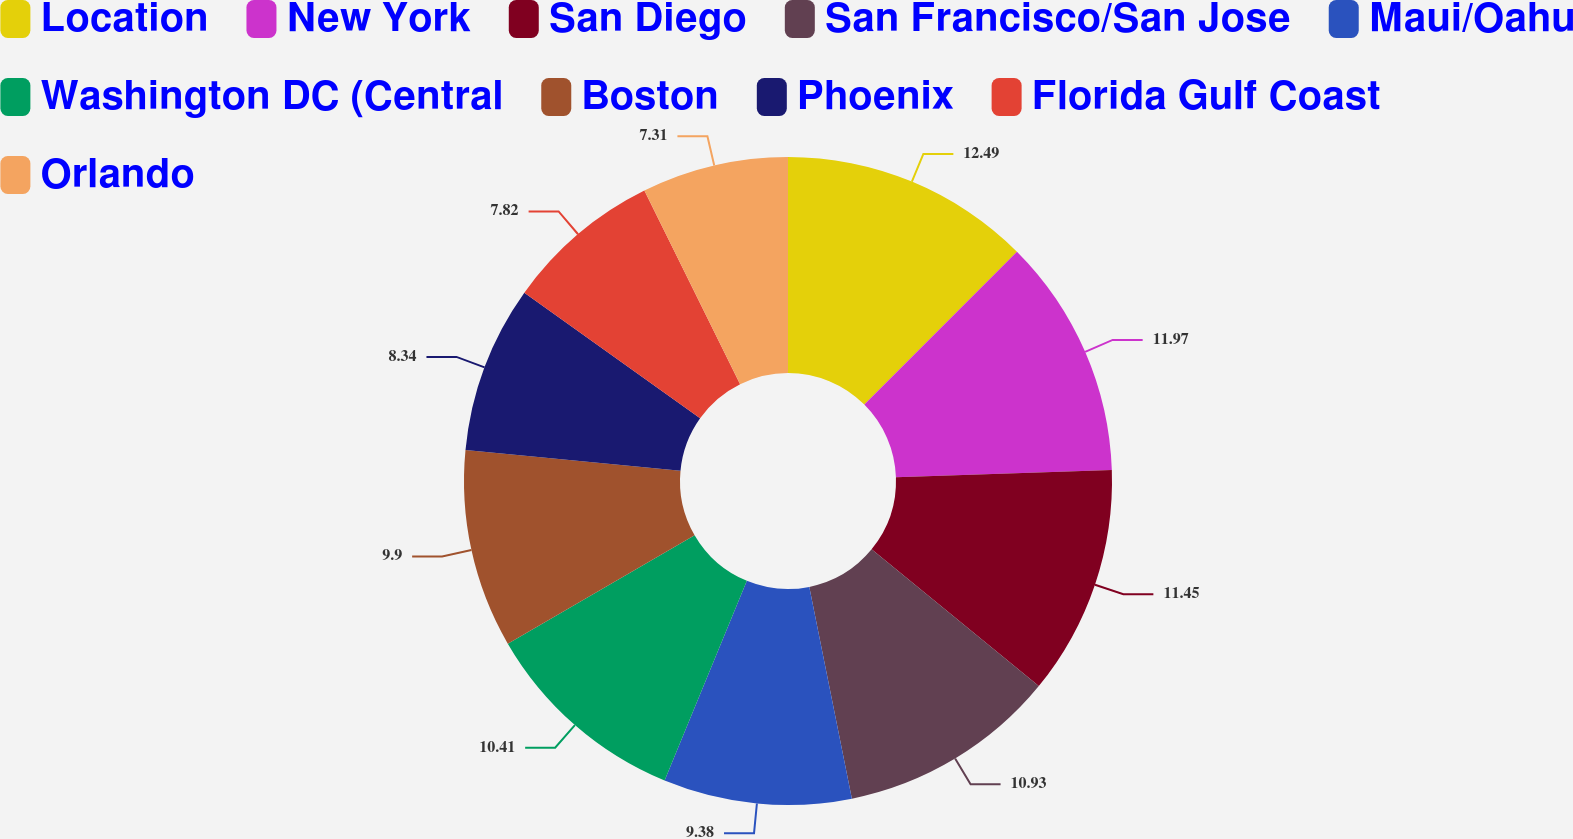<chart> <loc_0><loc_0><loc_500><loc_500><pie_chart><fcel>Location<fcel>New York<fcel>San Diego<fcel>San Francisco/San Jose<fcel>Maui/Oahu<fcel>Washington DC (Central<fcel>Boston<fcel>Phoenix<fcel>Florida Gulf Coast<fcel>Orlando<nl><fcel>12.49%<fcel>11.97%<fcel>11.45%<fcel>10.93%<fcel>9.38%<fcel>10.41%<fcel>9.9%<fcel>8.34%<fcel>7.82%<fcel>7.31%<nl></chart> 